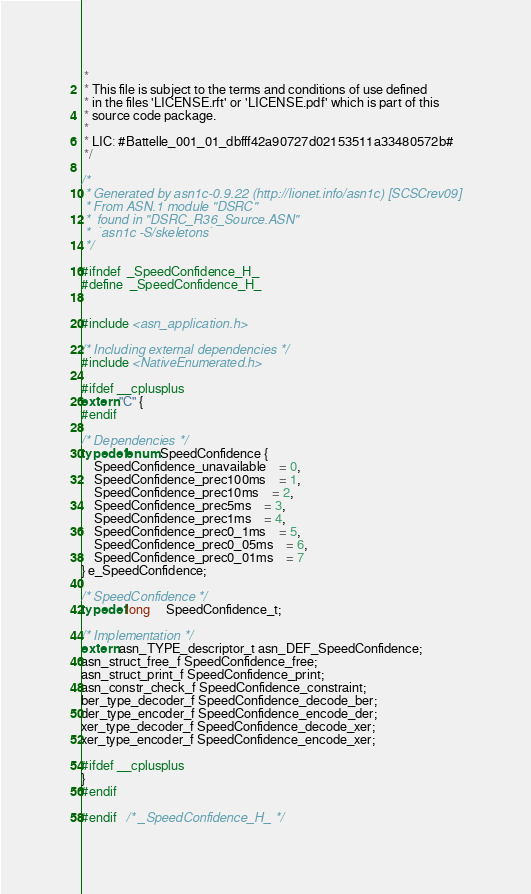Convert code to text. <code><loc_0><loc_0><loc_500><loc_500><_C_> *
 * This file is subject to the terms and conditions of use defined 
 * in the files 'LICENSE.rft' or 'LICENSE.pdf' which is part of this 
 * source code package.
 *
 * LIC: #Battelle_001_01_dbfff42a90727d02153511a33480572b#
 */

/*
 * Generated by asn1c-0.9.22 (http://lionet.info/asn1c) [SCSCrev09]
 * From ASN.1 module "DSRC"
 * 	found in "DSRC_R36_Source.ASN"
 * 	`asn1c -S/skeletons`
 */

#ifndef	_SpeedConfidence_H_
#define	_SpeedConfidence_H_


#include <asn_application.h>

/* Including external dependencies */
#include <NativeEnumerated.h>

#ifdef __cplusplus
extern "C" {
#endif

/* Dependencies */
typedef enum SpeedConfidence {
	SpeedConfidence_unavailable	= 0,
	SpeedConfidence_prec100ms	= 1,
	SpeedConfidence_prec10ms	= 2,
	SpeedConfidence_prec5ms	= 3,
	SpeedConfidence_prec1ms	= 4,
	SpeedConfidence_prec0_1ms	= 5,
	SpeedConfidence_prec0_05ms	= 6,
	SpeedConfidence_prec0_01ms	= 7
} e_SpeedConfidence;

/* SpeedConfidence */
typedef long	 SpeedConfidence_t;

/* Implementation */
extern asn_TYPE_descriptor_t asn_DEF_SpeedConfidence;
asn_struct_free_f SpeedConfidence_free;
asn_struct_print_f SpeedConfidence_print;
asn_constr_check_f SpeedConfidence_constraint;
ber_type_decoder_f SpeedConfidence_decode_ber;
der_type_encoder_f SpeedConfidence_encode_der;
xer_type_decoder_f SpeedConfidence_decode_xer;
xer_type_encoder_f SpeedConfidence_encode_xer;

#ifdef __cplusplus
}
#endif

#endif	/* _SpeedConfidence_H_ */
</code> 